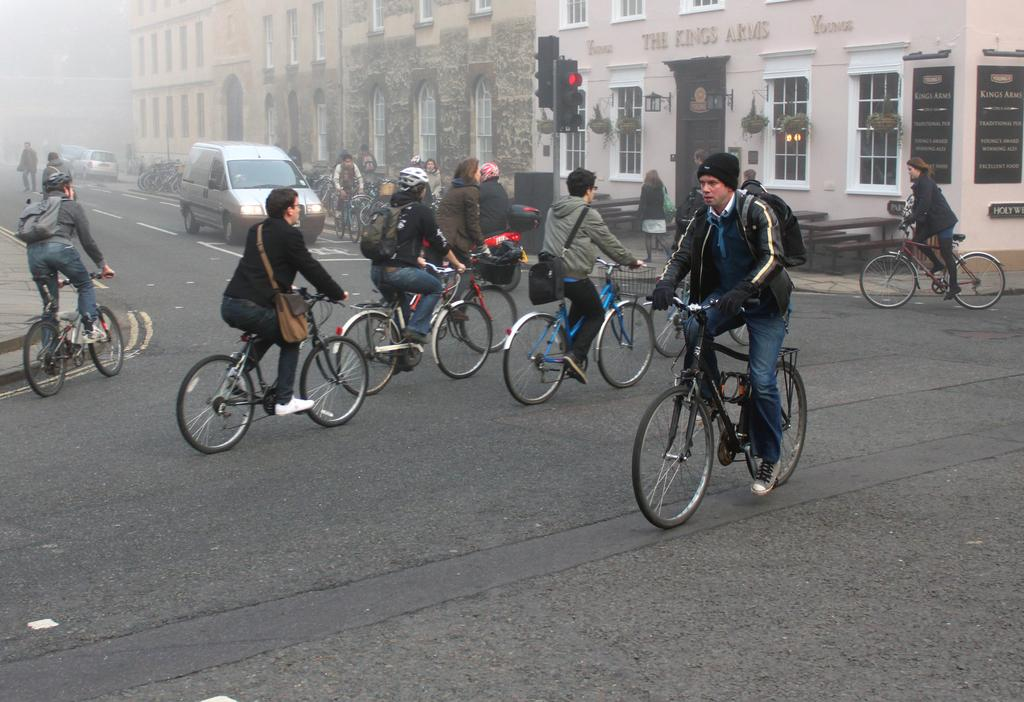What are the people in the image doing? The people in the image are riding bicycles on the road. What helps regulate traffic in the image? There are traffic signals on poles to regulate traffic. What types of vehicles can be seen in the image? Vehicles are present in the image. What type of structures are visible in the image? There are buildings and houses with plants visible in the image. What type of furniture is present in the image? Tables and benches are visible in the image. What other objects can be seen in the image? Boards are present in the image. How would you describe the background of the image? The background is blurred. Where is the drawer located in the image? There is no drawer present in the image. What type of fowl can be seen flying in the image? There are no birds or fowl visible in the image. 